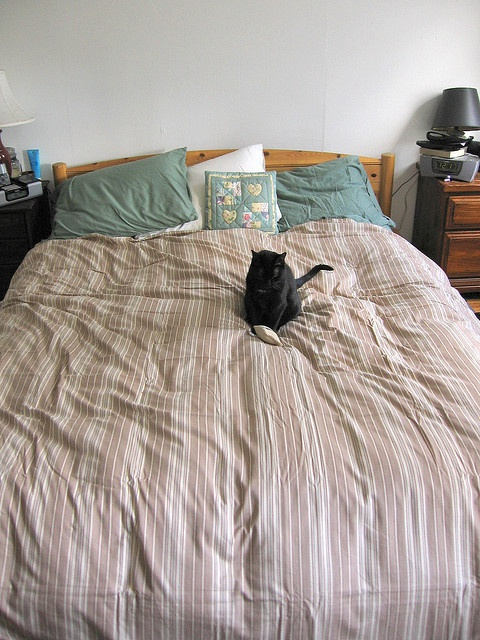Describe the objects in this image and their specific colors. I can see bed in darkgray, lightgray, and gray tones, cat in darkgray, black, and gray tones, clock in darkgray, gray, black, and lightgray tones, book in darkgray, gray, ivory, and black tones, and clock in darkgray, black, and gray tones in this image. 